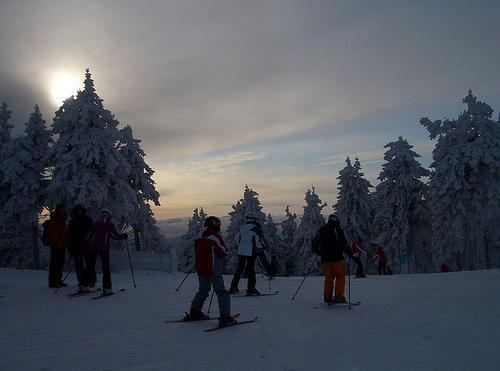What is touching the snow?
Pick the correct solution from the four options below to address the question.
Options: Cats paw, skis, dogs paw, cowboy boots. Skis. 